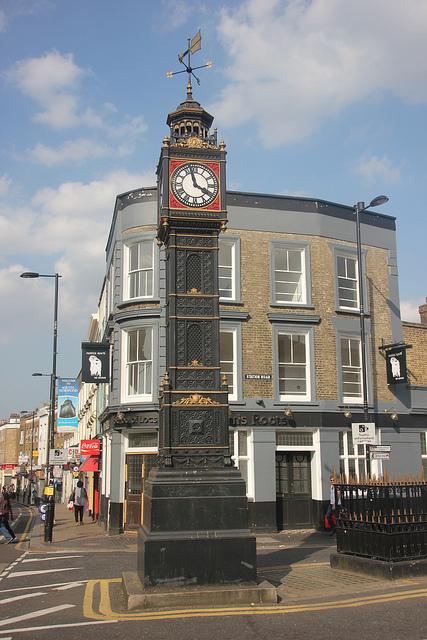How many people are on the sidewalk?
Keep it brief. 1. Are the lights on in the building?
Short answer required. No. How many clocks are there?
Give a very brief answer. 1. What time is it?
Quick response, please. 11:20. Where is the clock?
Short answer required. Tower. 